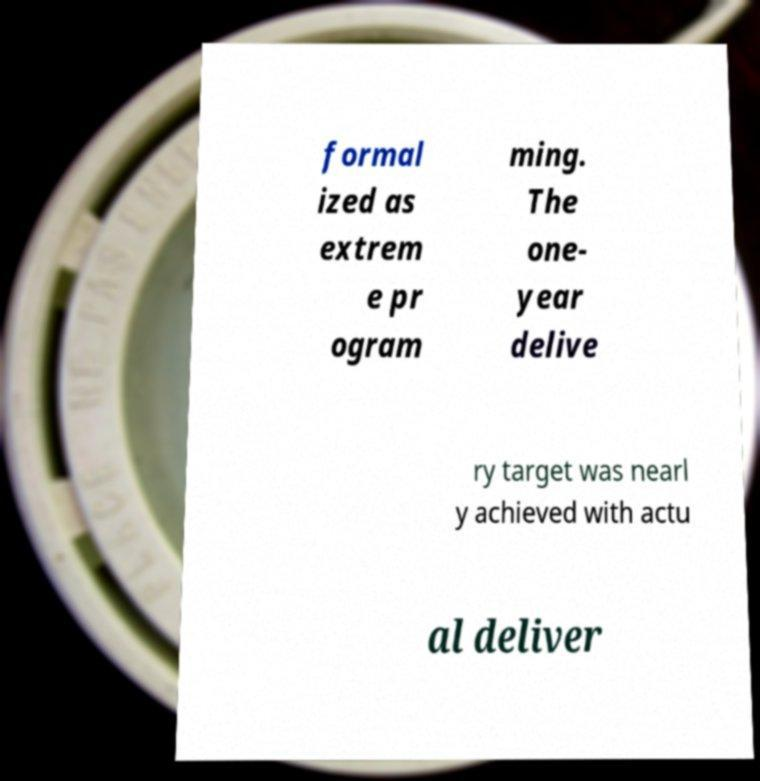There's text embedded in this image that I need extracted. Can you transcribe it verbatim? formal ized as extrem e pr ogram ming. The one- year delive ry target was nearl y achieved with actu al deliver 